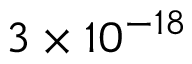<formula> <loc_0><loc_0><loc_500><loc_500>3 \times 1 0 ^ { - 1 8 }</formula> 